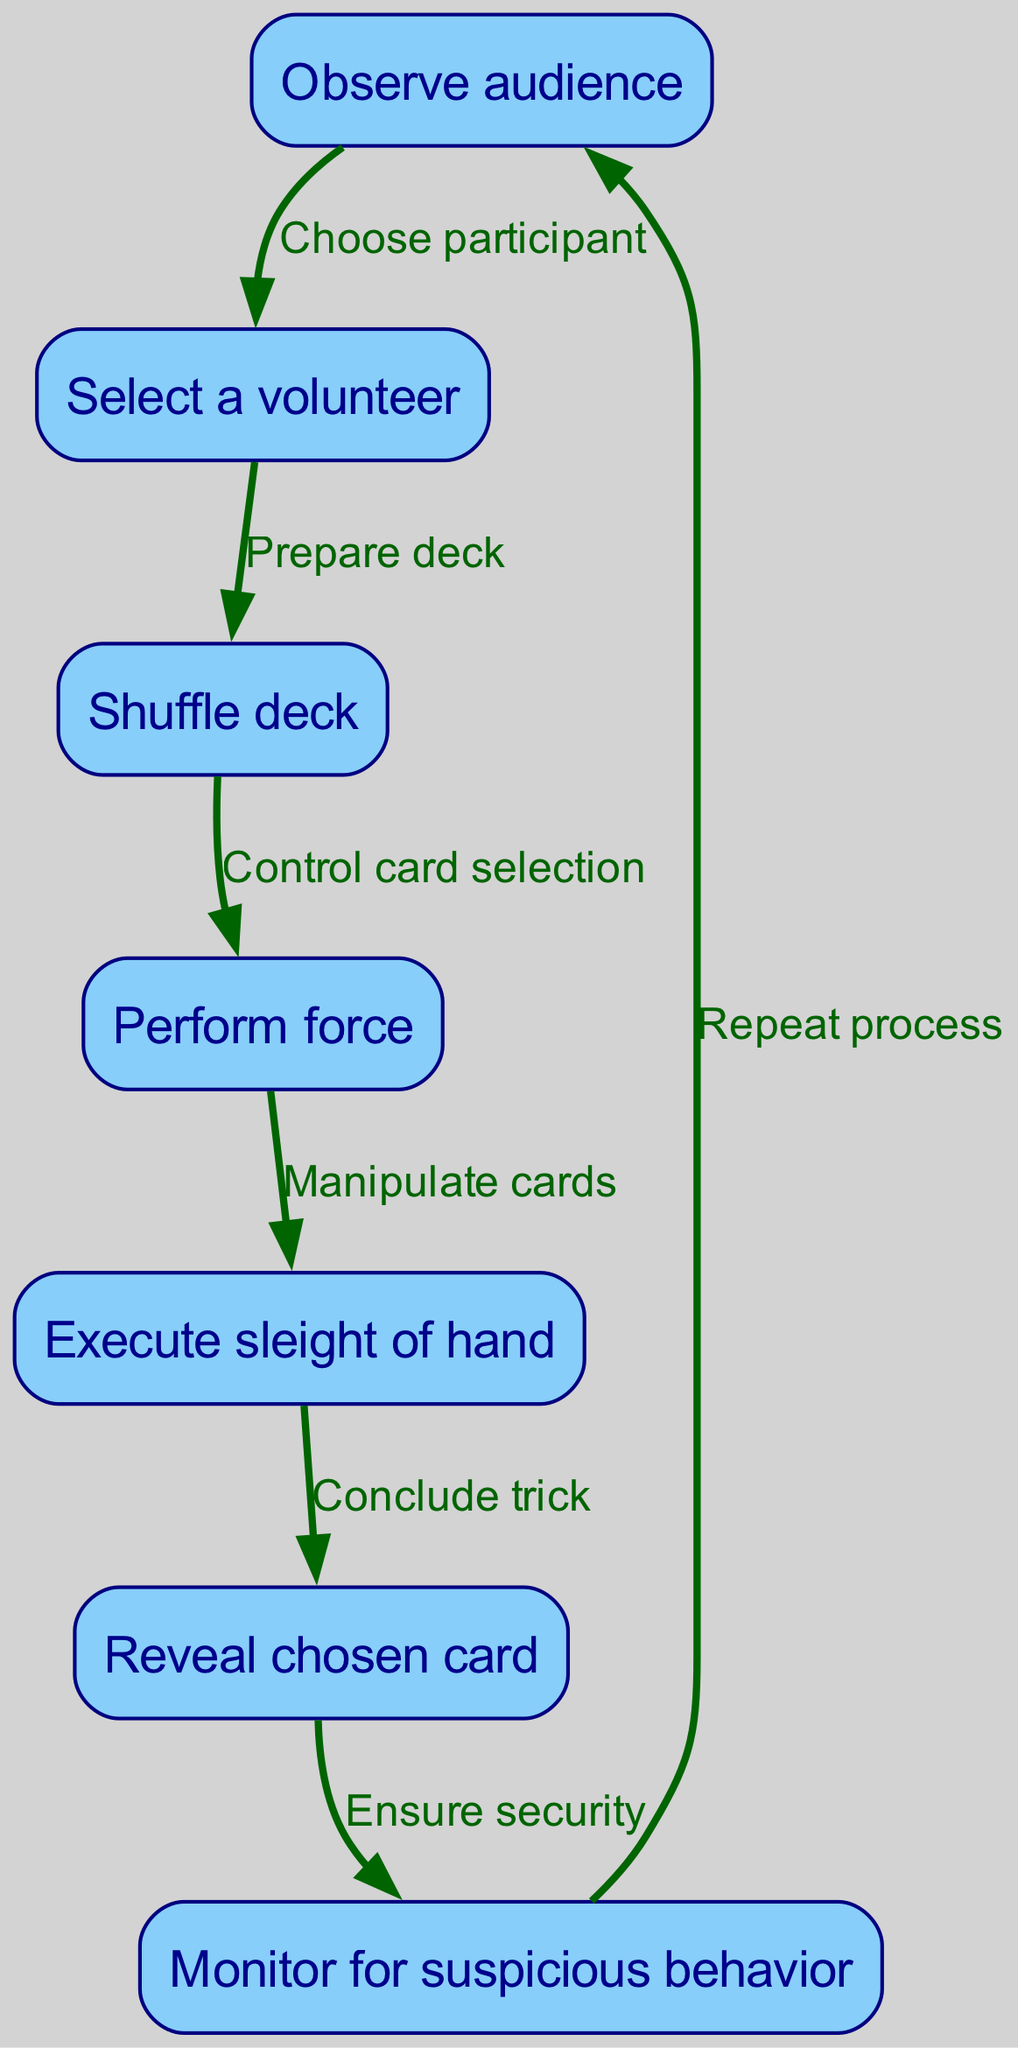What is the first step in the card trick performance? The first node in the flow chart represents the initial action, which is to "Observe audience." This is the starting point of the performance sequence.
Answer: Observe audience How many nodes are present in the diagram? By counting the distinct actions or steps represented in the nodes section of the diagram, I find there are seven unique nodes listed.
Answer: 7 What action follows “Select a volunteer”? Following the action "Select a volunteer," the next defined action in the flow chart is "Shuffle deck," indicating the preparatory steps before performing the trick.
Answer: Shuffle deck What is the final action before the process cycles back? The final action in the flow chart before returning to the start is "Ensure security," which relates to monitoring the audience after revealing the card.
Answer: Ensure security What is the relationship between “Perform force” and “Execute sleight of hand”? The relationship is that “Perform force” leads directly to “Execute sleight of hand.” This means that after performing the force in the trick, the magician manipulates the cards with sleight of hand as the next step in the sequence.
Answer: Manipulate cards Which action includes "Conclude trick" as the next step? The action "Execute sleight of hand" is followed by "Conclude trick," meaning after the sleight, the magician wraps up the performance by revealing the chosen card.
Answer: Execute sleight of hand What does “Reveal chosen card” lead to? After the action "Reveal chosen card," the next action specified in the flow chart is "Ensure security," indicating a transition from the performance to ensuring the audience's safety and trust.
Answer: Ensure security What indicates the flow returns to the beginning of the process? The edge connecting “Ensure security” to “Observe audience” shows that after ensuring security, the magician is prompted to start the process anew, indicating a repeat of the performance sequence.
Answer: Repeat process 